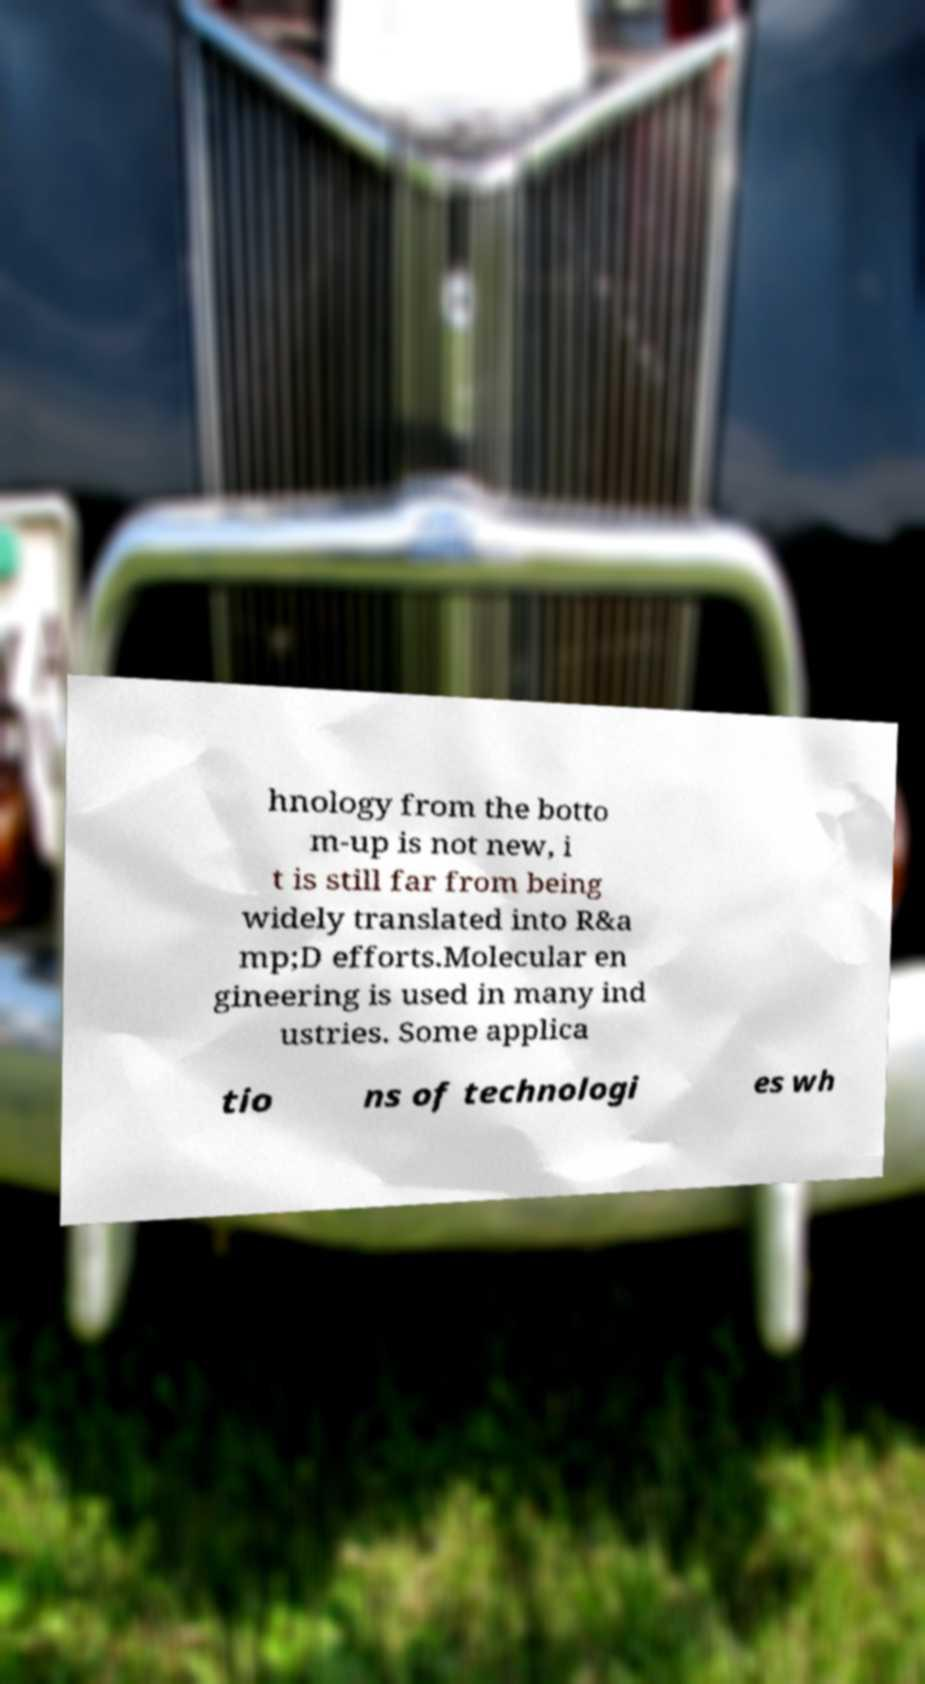There's text embedded in this image that I need extracted. Can you transcribe it verbatim? hnology from the botto m-up is not new, i t is still far from being widely translated into R&a mp;D efforts.Molecular en gineering is used in many ind ustries. Some applica tio ns of technologi es wh 